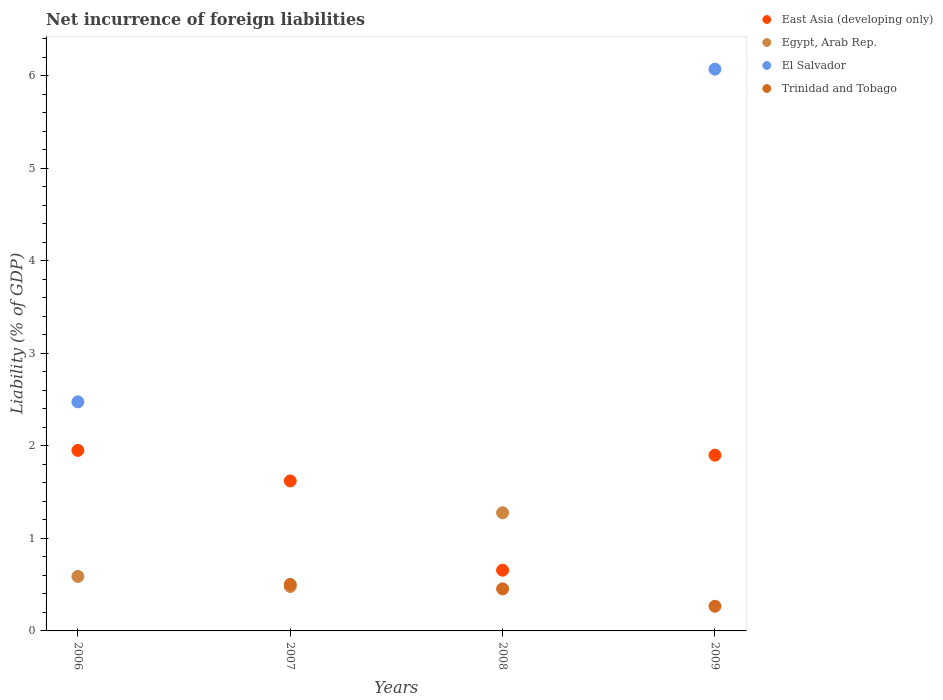How many different coloured dotlines are there?
Provide a short and direct response. 4. What is the net incurrence of foreign liabilities in Egypt, Arab Rep. in 2007?
Offer a very short reply. 0.48. Across all years, what is the maximum net incurrence of foreign liabilities in Trinidad and Tobago?
Your answer should be compact. 0.5. In which year was the net incurrence of foreign liabilities in Trinidad and Tobago maximum?
Offer a very short reply. 2007. What is the total net incurrence of foreign liabilities in Egypt, Arab Rep. in the graph?
Provide a short and direct response. 2.35. What is the difference between the net incurrence of foreign liabilities in Trinidad and Tobago in 2007 and that in 2008?
Provide a short and direct response. 0.05. What is the difference between the net incurrence of foreign liabilities in Egypt, Arab Rep. in 2006 and the net incurrence of foreign liabilities in East Asia (developing only) in 2009?
Provide a short and direct response. -1.31. What is the average net incurrence of foreign liabilities in Trinidad and Tobago per year?
Offer a terse response. 0.31. In the year 2009, what is the difference between the net incurrence of foreign liabilities in El Salvador and net incurrence of foreign liabilities in Trinidad and Tobago?
Offer a terse response. 5.81. What is the ratio of the net incurrence of foreign liabilities in East Asia (developing only) in 2006 to that in 2009?
Offer a very short reply. 1.03. Is the net incurrence of foreign liabilities in East Asia (developing only) in 2007 less than that in 2009?
Ensure brevity in your answer.  Yes. What is the difference between the highest and the second highest net incurrence of foreign liabilities in East Asia (developing only)?
Keep it short and to the point. 0.05. What is the difference between the highest and the lowest net incurrence of foreign liabilities in East Asia (developing only)?
Keep it short and to the point. 1.3. In how many years, is the net incurrence of foreign liabilities in East Asia (developing only) greater than the average net incurrence of foreign liabilities in East Asia (developing only) taken over all years?
Offer a terse response. 3. Is it the case that in every year, the sum of the net incurrence of foreign liabilities in Egypt, Arab Rep. and net incurrence of foreign liabilities in El Salvador  is greater than the net incurrence of foreign liabilities in Trinidad and Tobago?
Ensure brevity in your answer.  No. Does the net incurrence of foreign liabilities in Egypt, Arab Rep. monotonically increase over the years?
Provide a short and direct response. No. How many dotlines are there?
Your answer should be very brief. 4. How many years are there in the graph?
Your answer should be compact. 4. What is the difference between two consecutive major ticks on the Y-axis?
Your answer should be compact. 1. Are the values on the major ticks of Y-axis written in scientific E-notation?
Offer a terse response. No. Does the graph contain any zero values?
Offer a terse response. Yes. Does the graph contain grids?
Keep it short and to the point. No. How are the legend labels stacked?
Ensure brevity in your answer.  Vertical. What is the title of the graph?
Keep it short and to the point. Net incurrence of foreign liabilities. Does "Portugal" appear as one of the legend labels in the graph?
Provide a succinct answer. No. What is the label or title of the X-axis?
Your answer should be compact. Years. What is the label or title of the Y-axis?
Give a very brief answer. Liability (% of GDP). What is the Liability (% of GDP) in East Asia (developing only) in 2006?
Make the answer very short. 1.95. What is the Liability (% of GDP) of Egypt, Arab Rep. in 2006?
Ensure brevity in your answer.  0.59. What is the Liability (% of GDP) in El Salvador in 2006?
Make the answer very short. 2.48. What is the Liability (% of GDP) in Trinidad and Tobago in 2006?
Your response must be concise. 0. What is the Liability (% of GDP) of East Asia (developing only) in 2007?
Give a very brief answer. 1.62. What is the Liability (% of GDP) of Egypt, Arab Rep. in 2007?
Make the answer very short. 0.48. What is the Liability (% of GDP) in El Salvador in 2007?
Ensure brevity in your answer.  0. What is the Liability (% of GDP) of Trinidad and Tobago in 2007?
Offer a very short reply. 0.5. What is the Liability (% of GDP) in East Asia (developing only) in 2008?
Provide a short and direct response. 0.66. What is the Liability (% of GDP) in Egypt, Arab Rep. in 2008?
Offer a very short reply. 1.28. What is the Liability (% of GDP) of Trinidad and Tobago in 2008?
Ensure brevity in your answer.  0.45. What is the Liability (% of GDP) in East Asia (developing only) in 2009?
Ensure brevity in your answer.  1.9. What is the Liability (% of GDP) of El Salvador in 2009?
Provide a succinct answer. 6.07. What is the Liability (% of GDP) of Trinidad and Tobago in 2009?
Offer a very short reply. 0.27. Across all years, what is the maximum Liability (% of GDP) in East Asia (developing only)?
Your answer should be very brief. 1.95. Across all years, what is the maximum Liability (% of GDP) of Egypt, Arab Rep.?
Your answer should be very brief. 1.28. Across all years, what is the maximum Liability (% of GDP) of El Salvador?
Your answer should be very brief. 6.07. Across all years, what is the maximum Liability (% of GDP) of Trinidad and Tobago?
Make the answer very short. 0.5. Across all years, what is the minimum Liability (% of GDP) in East Asia (developing only)?
Your response must be concise. 0.66. Across all years, what is the minimum Liability (% of GDP) of El Salvador?
Provide a short and direct response. 0. Across all years, what is the minimum Liability (% of GDP) in Trinidad and Tobago?
Ensure brevity in your answer.  0. What is the total Liability (% of GDP) in East Asia (developing only) in the graph?
Your answer should be compact. 6.13. What is the total Liability (% of GDP) of Egypt, Arab Rep. in the graph?
Ensure brevity in your answer.  2.35. What is the total Liability (% of GDP) of El Salvador in the graph?
Provide a short and direct response. 8.55. What is the total Liability (% of GDP) of Trinidad and Tobago in the graph?
Provide a short and direct response. 1.22. What is the difference between the Liability (% of GDP) of East Asia (developing only) in 2006 and that in 2007?
Ensure brevity in your answer.  0.33. What is the difference between the Liability (% of GDP) in Egypt, Arab Rep. in 2006 and that in 2007?
Provide a succinct answer. 0.11. What is the difference between the Liability (% of GDP) in East Asia (developing only) in 2006 and that in 2008?
Provide a short and direct response. 1.3. What is the difference between the Liability (% of GDP) in Egypt, Arab Rep. in 2006 and that in 2008?
Offer a terse response. -0.69. What is the difference between the Liability (% of GDP) in East Asia (developing only) in 2006 and that in 2009?
Your answer should be very brief. 0.05. What is the difference between the Liability (% of GDP) in El Salvador in 2006 and that in 2009?
Give a very brief answer. -3.6. What is the difference between the Liability (% of GDP) of East Asia (developing only) in 2007 and that in 2008?
Your response must be concise. 0.96. What is the difference between the Liability (% of GDP) of Egypt, Arab Rep. in 2007 and that in 2008?
Your answer should be very brief. -0.8. What is the difference between the Liability (% of GDP) of Trinidad and Tobago in 2007 and that in 2008?
Offer a very short reply. 0.05. What is the difference between the Liability (% of GDP) in East Asia (developing only) in 2007 and that in 2009?
Your answer should be very brief. -0.28. What is the difference between the Liability (% of GDP) of Trinidad and Tobago in 2007 and that in 2009?
Keep it short and to the point. 0.24. What is the difference between the Liability (% of GDP) in East Asia (developing only) in 2008 and that in 2009?
Give a very brief answer. -1.24. What is the difference between the Liability (% of GDP) of Trinidad and Tobago in 2008 and that in 2009?
Offer a terse response. 0.19. What is the difference between the Liability (% of GDP) in East Asia (developing only) in 2006 and the Liability (% of GDP) in Egypt, Arab Rep. in 2007?
Your answer should be compact. 1.47. What is the difference between the Liability (% of GDP) of East Asia (developing only) in 2006 and the Liability (% of GDP) of Trinidad and Tobago in 2007?
Offer a terse response. 1.45. What is the difference between the Liability (% of GDP) in Egypt, Arab Rep. in 2006 and the Liability (% of GDP) in Trinidad and Tobago in 2007?
Your response must be concise. 0.09. What is the difference between the Liability (% of GDP) of El Salvador in 2006 and the Liability (% of GDP) of Trinidad and Tobago in 2007?
Give a very brief answer. 1.97. What is the difference between the Liability (% of GDP) in East Asia (developing only) in 2006 and the Liability (% of GDP) in Egypt, Arab Rep. in 2008?
Make the answer very short. 0.67. What is the difference between the Liability (% of GDP) of East Asia (developing only) in 2006 and the Liability (% of GDP) of Trinidad and Tobago in 2008?
Keep it short and to the point. 1.5. What is the difference between the Liability (% of GDP) of Egypt, Arab Rep. in 2006 and the Liability (% of GDP) of Trinidad and Tobago in 2008?
Keep it short and to the point. 0.13. What is the difference between the Liability (% of GDP) in El Salvador in 2006 and the Liability (% of GDP) in Trinidad and Tobago in 2008?
Your answer should be compact. 2.02. What is the difference between the Liability (% of GDP) in East Asia (developing only) in 2006 and the Liability (% of GDP) in El Salvador in 2009?
Keep it short and to the point. -4.12. What is the difference between the Liability (% of GDP) of East Asia (developing only) in 2006 and the Liability (% of GDP) of Trinidad and Tobago in 2009?
Make the answer very short. 1.69. What is the difference between the Liability (% of GDP) of Egypt, Arab Rep. in 2006 and the Liability (% of GDP) of El Salvador in 2009?
Keep it short and to the point. -5.48. What is the difference between the Liability (% of GDP) in Egypt, Arab Rep. in 2006 and the Liability (% of GDP) in Trinidad and Tobago in 2009?
Provide a succinct answer. 0.32. What is the difference between the Liability (% of GDP) in El Salvador in 2006 and the Liability (% of GDP) in Trinidad and Tobago in 2009?
Keep it short and to the point. 2.21. What is the difference between the Liability (% of GDP) in East Asia (developing only) in 2007 and the Liability (% of GDP) in Egypt, Arab Rep. in 2008?
Your response must be concise. 0.34. What is the difference between the Liability (% of GDP) of East Asia (developing only) in 2007 and the Liability (% of GDP) of Trinidad and Tobago in 2008?
Provide a succinct answer. 1.17. What is the difference between the Liability (% of GDP) in Egypt, Arab Rep. in 2007 and the Liability (% of GDP) in Trinidad and Tobago in 2008?
Your response must be concise. 0.03. What is the difference between the Liability (% of GDP) of East Asia (developing only) in 2007 and the Liability (% of GDP) of El Salvador in 2009?
Your answer should be compact. -4.45. What is the difference between the Liability (% of GDP) of East Asia (developing only) in 2007 and the Liability (% of GDP) of Trinidad and Tobago in 2009?
Offer a terse response. 1.35. What is the difference between the Liability (% of GDP) of Egypt, Arab Rep. in 2007 and the Liability (% of GDP) of El Salvador in 2009?
Your answer should be compact. -5.59. What is the difference between the Liability (% of GDP) of Egypt, Arab Rep. in 2007 and the Liability (% of GDP) of Trinidad and Tobago in 2009?
Keep it short and to the point. 0.21. What is the difference between the Liability (% of GDP) in East Asia (developing only) in 2008 and the Liability (% of GDP) in El Salvador in 2009?
Provide a short and direct response. -5.42. What is the difference between the Liability (% of GDP) of East Asia (developing only) in 2008 and the Liability (% of GDP) of Trinidad and Tobago in 2009?
Provide a succinct answer. 0.39. What is the difference between the Liability (% of GDP) of Egypt, Arab Rep. in 2008 and the Liability (% of GDP) of El Salvador in 2009?
Ensure brevity in your answer.  -4.8. What is the difference between the Liability (% of GDP) of Egypt, Arab Rep. in 2008 and the Liability (% of GDP) of Trinidad and Tobago in 2009?
Ensure brevity in your answer.  1.01. What is the average Liability (% of GDP) in East Asia (developing only) per year?
Provide a short and direct response. 1.53. What is the average Liability (% of GDP) in Egypt, Arab Rep. per year?
Your response must be concise. 0.59. What is the average Liability (% of GDP) in El Salvador per year?
Give a very brief answer. 2.14. What is the average Liability (% of GDP) of Trinidad and Tobago per year?
Give a very brief answer. 0.31. In the year 2006, what is the difference between the Liability (% of GDP) in East Asia (developing only) and Liability (% of GDP) in Egypt, Arab Rep.?
Make the answer very short. 1.36. In the year 2006, what is the difference between the Liability (% of GDP) in East Asia (developing only) and Liability (% of GDP) in El Salvador?
Keep it short and to the point. -0.52. In the year 2006, what is the difference between the Liability (% of GDP) of Egypt, Arab Rep. and Liability (% of GDP) of El Salvador?
Offer a terse response. -1.89. In the year 2007, what is the difference between the Liability (% of GDP) in East Asia (developing only) and Liability (% of GDP) in Egypt, Arab Rep.?
Your answer should be compact. 1.14. In the year 2007, what is the difference between the Liability (% of GDP) in East Asia (developing only) and Liability (% of GDP) in Trinidad and Tobago?
Provide a short and direct response. 1.12. In the year 2007, what is the difference between the Liability (% of GDP) in Egypt, Arab Rep. and Liability (% of GDP) in Trinidad and Tobago?
Give a very brief answer. -0.02. In the year 2008, what is the difference between the Liability (% of GDP) in East Asia (developing only) and Liability (% of GDP) in Egypt, Arab Rep.?
Your answer should be compact. -0.62. In the year 2008, what is the difference between the Liability (% of GDP) in East Asia (developing only) and Liability (% of GDP) in Trinidad and Tobago?
Your answer should be compact. 0.2. In the year 2008, what is the difference between the Liability (% of GDP) of Egypt, Arab Rep. and Liability (% of GDP) of Trinidad and Tobago?
Your response must be concise. 0.82. In the year 2009, what is the difference between the Liability (% of GDP) of East Asia (developing only) and Liability (% of GDP) of El Salvador?
Keep it short and to the point. -4.17. In the year 2009, what is the difference between the Liability (% of GDP) of East Asia (developing only) and Liability (% of GDP) of Trinidad and Tobago?
Ensure brevity in your answer.  1.63. In the year 2009, what is the difference between the Liability (% of GDP) in El Salvador and Liability (% of GDP) in Trinidad and Tobago?
Make the answer very short. 5.81. What is the ratio of the Liability (% of GDP) of East Asia (developing only) in 2006 to that in 2007?
Your answer should be very brief. 1.2. What is the ratio of the Liability (% of GDP) in Egypt, Arab Rep. in 2006 to that in 2007?
Provide a short and direct response. 1.23. What is the ratio of the Liability (% of GDP) of East Asia (developing only) in 2006 to that in 2008?
Keep it short and to the point. 2.97. What is the ratio of the Liability (% of GDP) in Egypt, Arab Rep. in 2006 to that in 2008?
Make the answer very short. 0.46. What is the ratio of the Liability (% of GDP) in East Asia (developing only) in 2006 to that in 2009?
Ensure brevity in your answer.  1.03. What is the ratio of the Liability (% of GDP) of El Salvador in 2006 to that in 2009?
Give a very brief answer. 0.41. What is the ratio of the Liability (% of GDP) of East Asia (developing only) in 2007 to that in 2008?
Your answer should be very brief. 2.47. What is the ratio of the Liability (% of GDP) of Egypt, Arab Rep. in 2007 to that in 2008?
Ensure brevity in your answer.  0.38. What is the ratio of the Liability (% of GDP) in Trinidad and Tobago in 2007 to that in 2008?
Provide a short and direct response. 1.11. What is the ratio of the Liability (% of GDP) of East Asia (developing only) in 2007 to that in 2009?
Your response must be concise. 0.85. What is the ratio of the Liability (% of GDP) in Trinidad and Tobago in 2007 to that in 2009?
Keep it short and to the point. 1.89. What is the ratio of the Liability (% of GDP) in East Asia (developing only) in 2008 to that in 2009?
Give a very brief answer. 0.35. What is the ratio of the Liability (% of GDP) of Trinidad and Tobago in 2008 to that in 2009?
Your answer should be compact. 1.71. What is the difference between the highest and the second highest Liability (% of GDP) of East Asia (developing only)?
Keep it short and to the point. 0.05. What is the difference between the highest and the second highest Liability (% of GDP) of Egypt, Arab Rep.?
Offer a very short reply. 0.69. What is the difference between the highest and the second highest Liability (% of GDP) of Trinidad and Tobago?
Keep it short and to the point. 0.05. What is the difference between the highest and the lowest Liability (% of GDP) in East Asia (developing only)?
Provide a short and direct response. 1.3. What is the difference between the highest and the lowest Liability (% of GDP) of Egypt, Arab Rep.?
Your answer should be very brief. 1.28. What is the difference between the highest and the lowest Liability (% of GDP) in El Salvador?
Your answer should be compact. 6.07. What is the difference between the highest and the lowest Liability (% of GDP) of Trinidad and Tobago?
Your response must be concise. 0.5. 